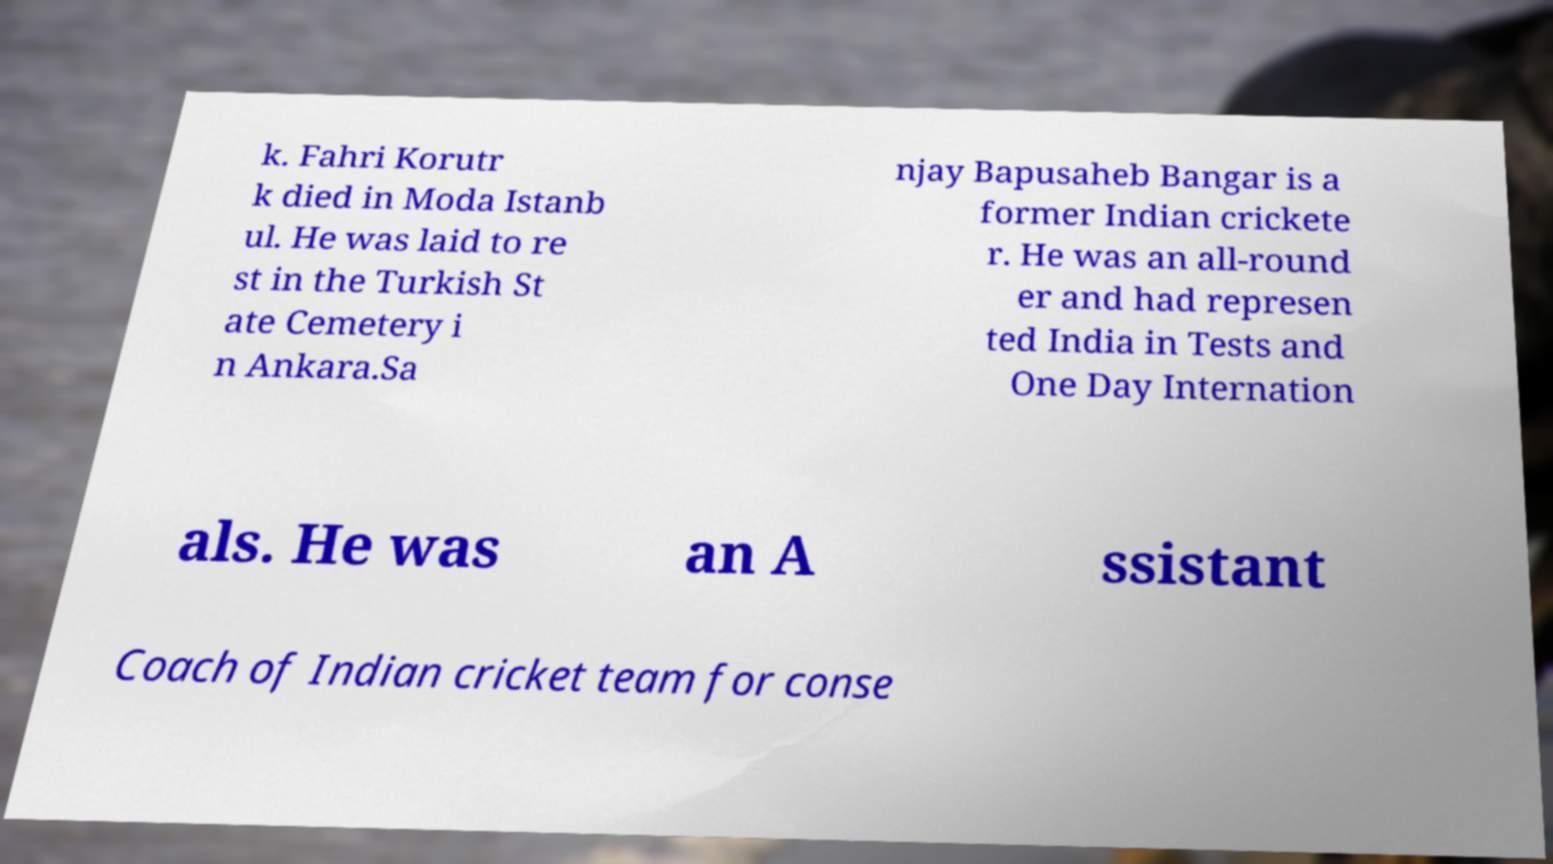Could you extract and type out the text from this image? k. Fahri Korutr k died in Moda Istanb ul. He was laid to re st in the Turkish St ate Cemetery i n Ankara.Sa njay Bapusaheb Bangar is a former Indian crickete r. He was an all-round er and had represen ted India in Tests and One Day Internation als. He was an A ssistant Coach of Indian cricket team for conse 